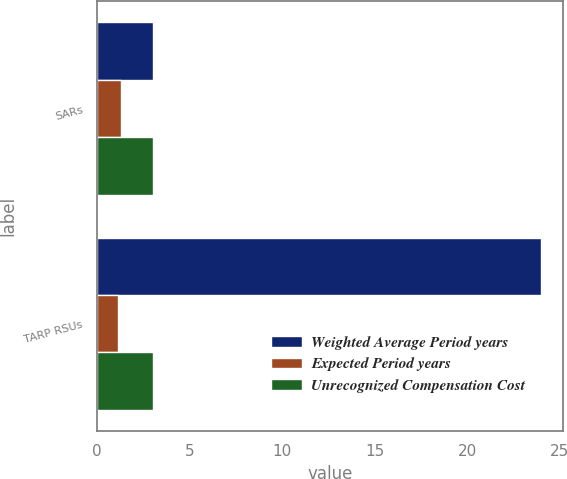Convert chart to OTSL. <chart><loc_0><loc_0><loc_500><loc_500><stacked_bar_chart><ecel><fcel>SARs<fcel>TARP RSUs<nl><fcel>Weighted Average Period years<fcel>3<fcel>24<nl><fcel>Expected Period years<fcel>1.3<fcel>1.15<nl><fcel>Unrecognized Compensation Cost<fcel>3<fcel>3<nl></chart> 